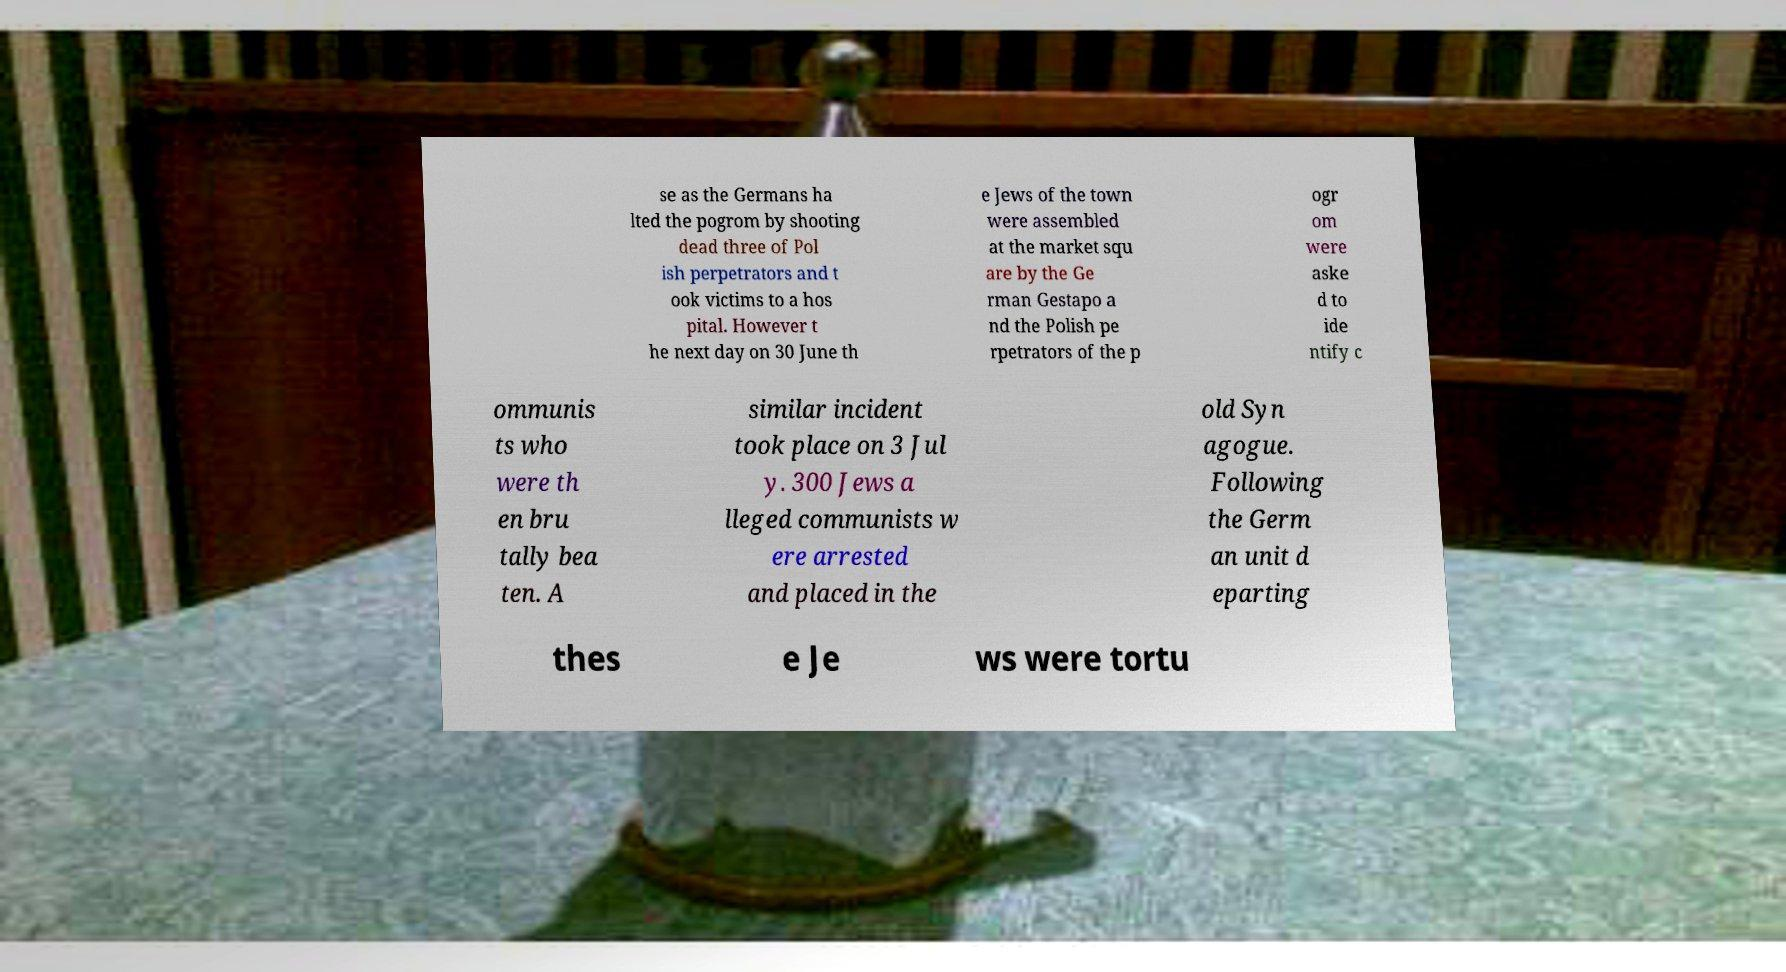Please read and relay the text visible in this image. What does it say? se as the Germans ha lted the pogrom by shooting dead three of Pol ish perpetrators and t ook victims to a hos pital. However t he next day on 30 June th e Jews of the town were assembled at the market squ are by the Ge rman Gestapo a nd the Polish pe rpetrators of the p ogr om were aske d to ide ntify c ommunis ts who were th en bru tally bea ten. A similar incident took place on 3 Jul y. 300 Jews a lleged communists w ere arrested and placed in the old Syn agogue. Following the Germ an unit d eparting thes e Je ws were tortu 